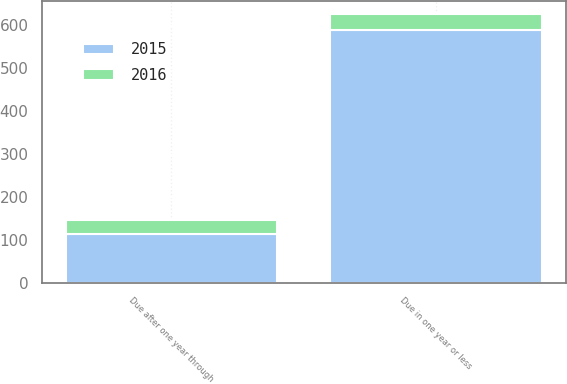<chart> <loc_0><loc_0><loc_500><loc_500><stacked_bar_chart><ecel><fcel>Due in one year or less<fcel>Due after one year through<nl><fcel>2016<fcel>36<fcel>32<nl><fcel>2015<fcel>588<fcel>114<nl></chart> 